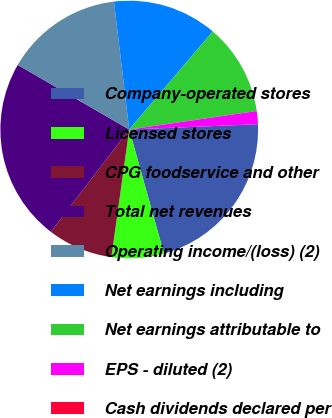Convert chart. <chart><loc_0><loc_0><loc_500><loc_500><pie_chart><fcel>Company-operated stores<fcel>Licensed stores<fcel>CPG foodservice and other<fcel>Total net revenues<fcel>Operating income/(loss) (2)<fcel>Net earnings including<fcel>Net earnings attributable to<fcel>EPS - diluted (2)<fcel>Cash dividends declared per<nl><fcel>21.31%<fcel>6.56%<fcel>8.2%<fcel>22.95%<fcel>14.75%<fcel>13.11%<fcel>11.48%<fcel>1.64%<fcel>0.0%<nl></chart> 